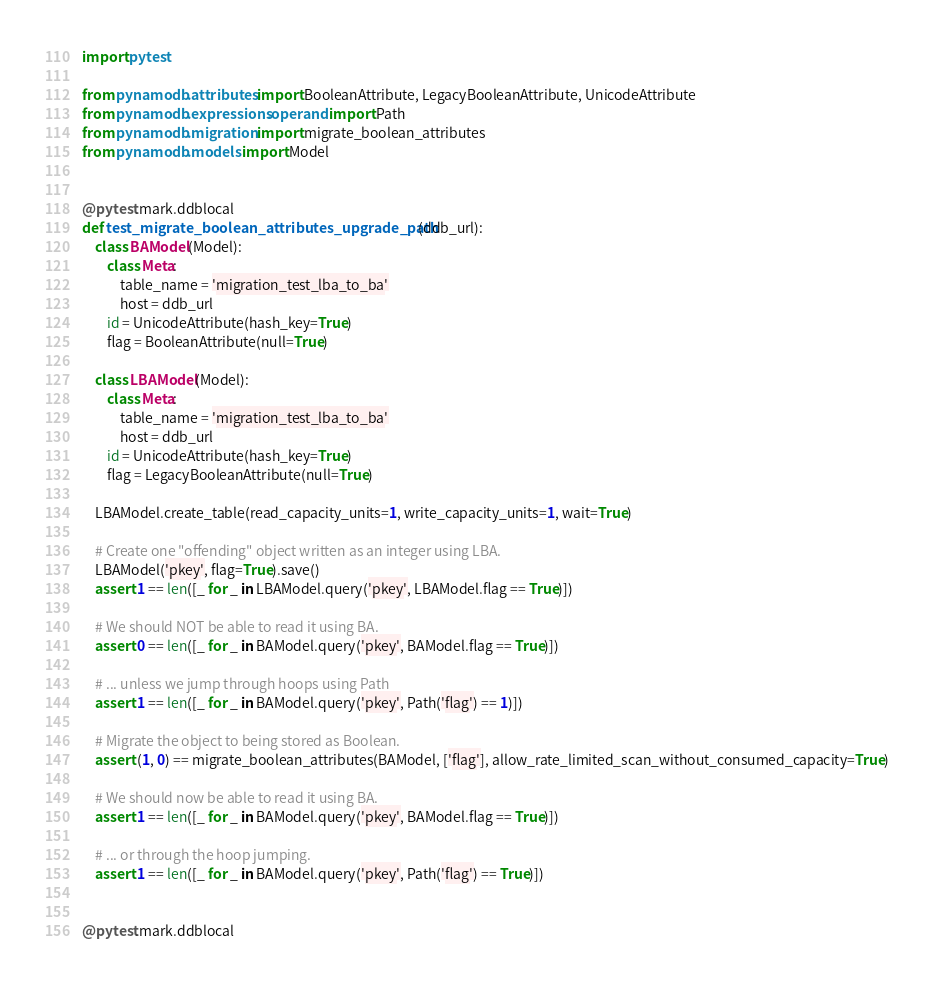Convert code to text. <code><loc_0><loc_0><loc_500><loc_500><_Python_>import pytest

from pynamodb.attributes import BooleanAttribute, LegacyBooleanAttribute, UnicodeAttribute
from pynamodb.expressions.operand import Path
from pynamodb.migration import migrate_boolean_attributes
from pynamodb.models import Model


@pytest.mark.ddblocal
def test_migrate_boolean_attributes_upgrade_path(ddb_url):
    class BAModel(Model):
        class Meta:
            table_name = 'migration_test_lba_to_ba'
            host = ddb_url
        id = UnicodeAttribute(hash_key=True)
        flag = BooleanAttribute(null=True)

    class LBAModel(Model):
        class Meta:
            table_name = 'migration_test_lba_to_ba'
            host = ddb_url
        id = UnicodeAttribute(hash_key=True)
        flag = LegacyBooleanAttribute(null=True)

    LBAModel.create_table(read_capacity_units=1, write_capacity_units=1, wait=True)

    # Create one "offending" object written as an integer using LBA.
    LBAModel('pkey', flag=True).save()
    assert 1 == len([_ for _ in LBAModel.query('pkey', LBAModel.flag == True)])

    # We should NOT be able to read it using BA.
    assert 0 == len([_ for _ in BAModel.query('pkey', BAModel.flag == True)])

    # ... unless we jump through hoops using Path
    assert 1 == len([_ for _ in BAModel.query('pkey', Path('flag') == 1)])

    # Migrate the object to being stored as Boolean.
    assert (1, 0) == migrate_boolean_attributes(BAModel, ['flag'], allow_rate_limited_scan_without_consumed_capacity=True)

    # We should now be able to read it using BA.
    assert 1 == len([_ for _ in BAModel.query('pkey', BAModel.flag == True)])

    # ... or through the hoop jumping.
    assert 1 == len([_ for _ in BAModel.query('pkey', Path('flag') == True)])


@pytest.mark.ddblocal</code> 